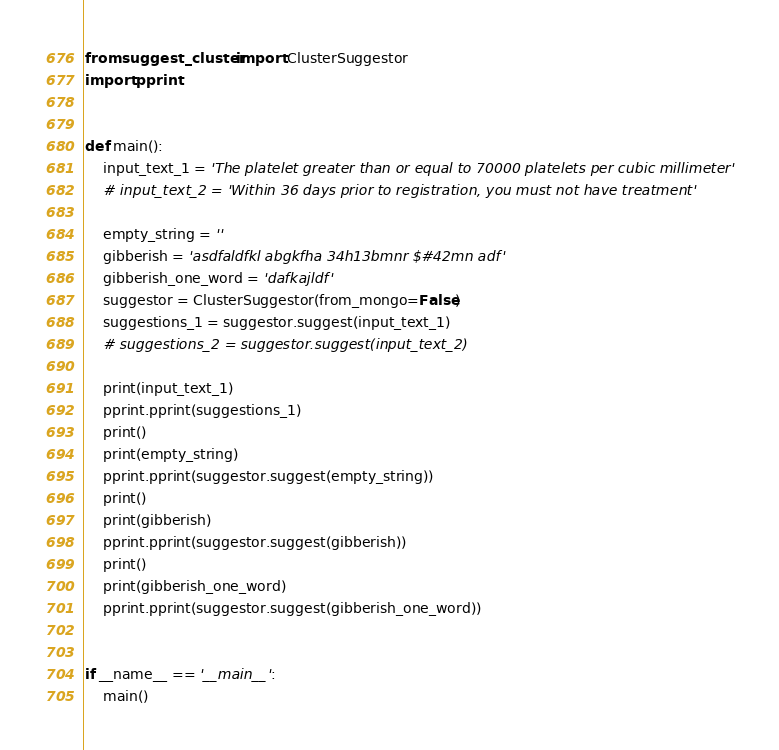Convert code to text. <code><loc_0><loc_0><loc_500><loc_500><_Python_>from suggest_cluster import ClusterSuggestor
import pprint


def main():
    input_text_1 = 'The platelet greater than or equal to 70000 platelets per cubic millimeter'
    # input_text_2 = 'Within 36 days prior to registration, you must not have treatment'

    empty_string = ''
    gibberish = 'asdfaldfkl abgkfha 34h13bmnr $#42mn adf'
    gibberish_one_word = 'dafkajldf'
    suggestor = ClusterSuggestor(from_mongo=False)
    suggestions_1 = suggestor.suggest(input_text_1)
    # suggestions_2 = suggestor.suggest(input_text_2)

    print(input_text_1)
    pprint.pprint(suggestions_1)
    print()
    print(empty_string)
    pprint.pprint(suggestor.suggest(empty_string))
    print()
    print(gibberish)
    pprint.pprint(suggestor.suggest(gibberish))
    print()
    print(gibberish_one_word)
    pprint.pprint(suggestor.suggest(gibberish_one_word))


if __name__ == '__main__':
    main()
</code> 